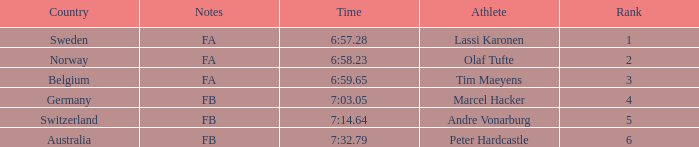What is the lowest rank for Andre Vonarburg, when the notes are FB? 5.0. 